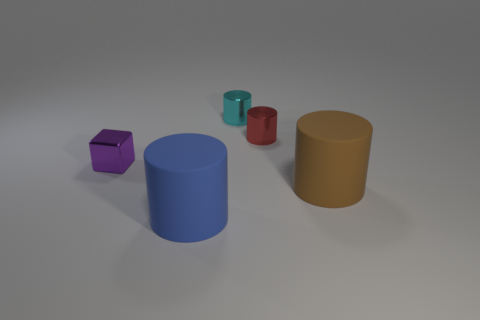What number of objects are either tiny yellow shiny objects or tiny metal blocks?
Give a very brief answer. 1. Is there anything else that has the same color as the block?
Keep it short and to the point. No. Is the material of the brown cylinder the same as the cylinder that is to the left of the tiny cyan shiny thing?
Ensure brevity in your answer.  Yes. There is a metallic thing that is left of the metal cylinder that is to the left of the small red thing; what shape is it?
Provide a succinct answer. Cube. There is a thing that is behind the brown cylinder and in front of the red metallic object; what is its shape?
Keep it short and to the point. Cube. What number of objects are either small cyan metal objects or tiny objects behind the tiny red object?
Keep it short and to the point. 1. There is a brown thing that is the same shape as the blue matte object; what is it made of?
Provide a short and direct response. Rubber. What material is the thing that is on the left side of the small red thing and behind the purple metal thing?
Offer a very short reply. Metal. How many small red metal objects have the same shape as the small cyan metal object?
Provide a succinct answer. 1. What color is the big matte object on the left side of the matte cylinder behind the large blue rubber thing?
Offer a terse response. Blue. 